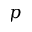Convert formula to latex. <formula><loc_0><loc_0><loc_500><loc_500>p</formula> 